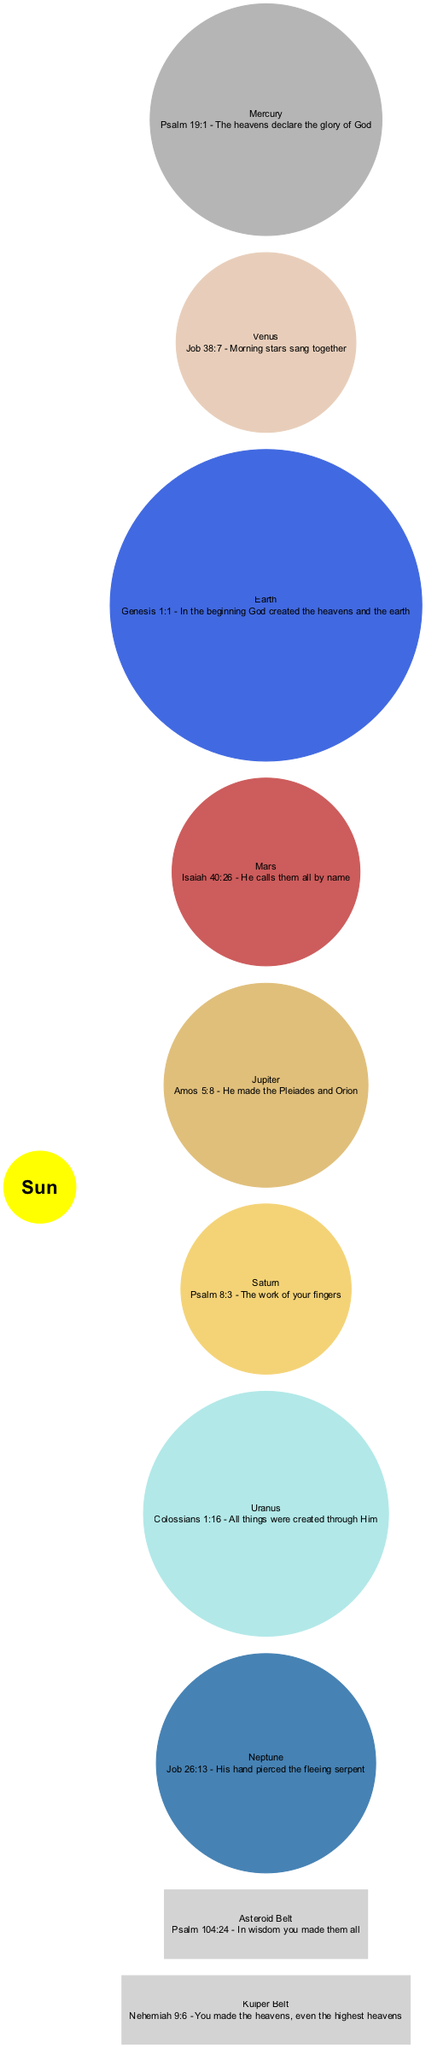What is at the center of the Solar System diagram? The diagram specifies that the Sun is placed at the center, indicating its importance and central position in the Solar System.
Answer: Sun How many planets are depicted in the diagram? The diagram lists a total of eight planets: Mercury, Venus, Earth, Mars, Jupiter, Saturn, Uranus, and Neptune. Thus, when we count, it totals to eight planets.
Answer: 8 Which planet is associated with the verse from Psalm 19:1? The verse from Psalm 19:1 mentions the glory of God as declared by the heavens. In the diagram, this verse is linked to Mercury, as it is the first planet listed.
Answer: Mercury Which celestial body is linked with the verse "He calls them all by name"? According to the diagram, the verse "He calls them all by name" from Isaiah 40:26 corresponds to Mars, which is the planet listed just before the next planet, Jupiter.
Answer: Mars What color is the planet Venus represented in the diagram? In the diagram, Venus is represented in a light, creamy color (#E8CEBA). This color differentiates it from other planets in the Solar System.
Answer: #E8CEBA What is the verse associated with the Kuiper Belt? The diagram specifies that the Kuiper Belt is linked with the verse "You made the heavens, even the highest heavens" from Nehemiah 9:6. This establishes a connection between this outer region and scriptural creativity.
Answer: Nehemiah 9:6 Which additional element is mentioned in the diagram alongside the planets? The diagram includes two additional elements: the Asteroid Belt and the Kuiper Belt. Each has its corresponding verse related to creation, but we can mention either for an answer.
Answer: Asteroid Belt Which planet has the verse "The work of your fingers"? The verse "The work of your fingers" is specifically linked to Saturn in the diagram, emphasizing God's creative work in the universe.
Answer: Saturn What is the color representation of Uranus in the diagram? The diagram describes Uranus as a light cyan color (#B2E8E8), distinguishing it visually from other planets in terms of color.
Answer: #B2E8E8 